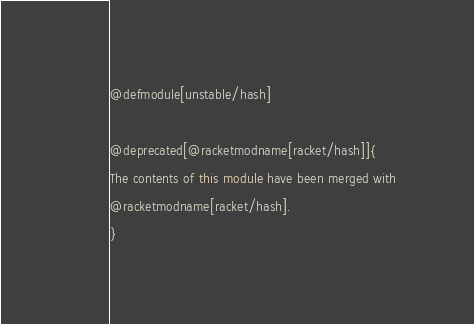<code> <loc_0><loc_0><loc_500><loc_500><_Racket_>@defmodule[unstable/hash]

@deprecated[@racketmodname[racket/hash]]{
The contents of this module have been merged with
@racketmodname[racket/hash].
}
</code> 